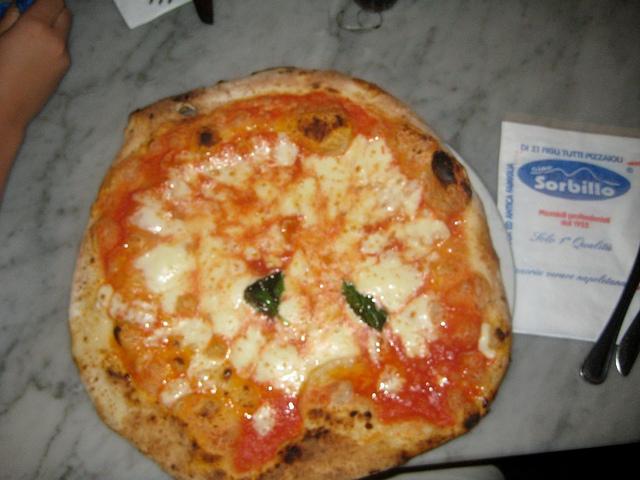What TV show is this food from?
Short answer required. Ninja turtles. How much sauce is on the pizza?
Be succinct. Little. Does this look like a scene from a kitchen, or from a restaurant?
Give a very brief answer. Restaurant. Why is the condiment packet taped to the box?
Write a very short answer. Safety. What type of cheese is that?
Be succinct. Mozzarella. Is the cheese melted?
Be succinct. Yes. Is there a "check" on the table?
Give a very brief answer. No. 